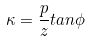Convert formula to latex. <formula><loc_0><loc_0><loc_500><loc_500>\kappa = \frac { p } { z } t a n \phi</formula> 